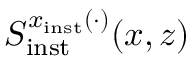<formula> <loc_0><loc_0><loc_500><loc_500>S _ { i n s t } ^ { x _ { i n s t } ( \cdot ) } ( x , z )</formula> 